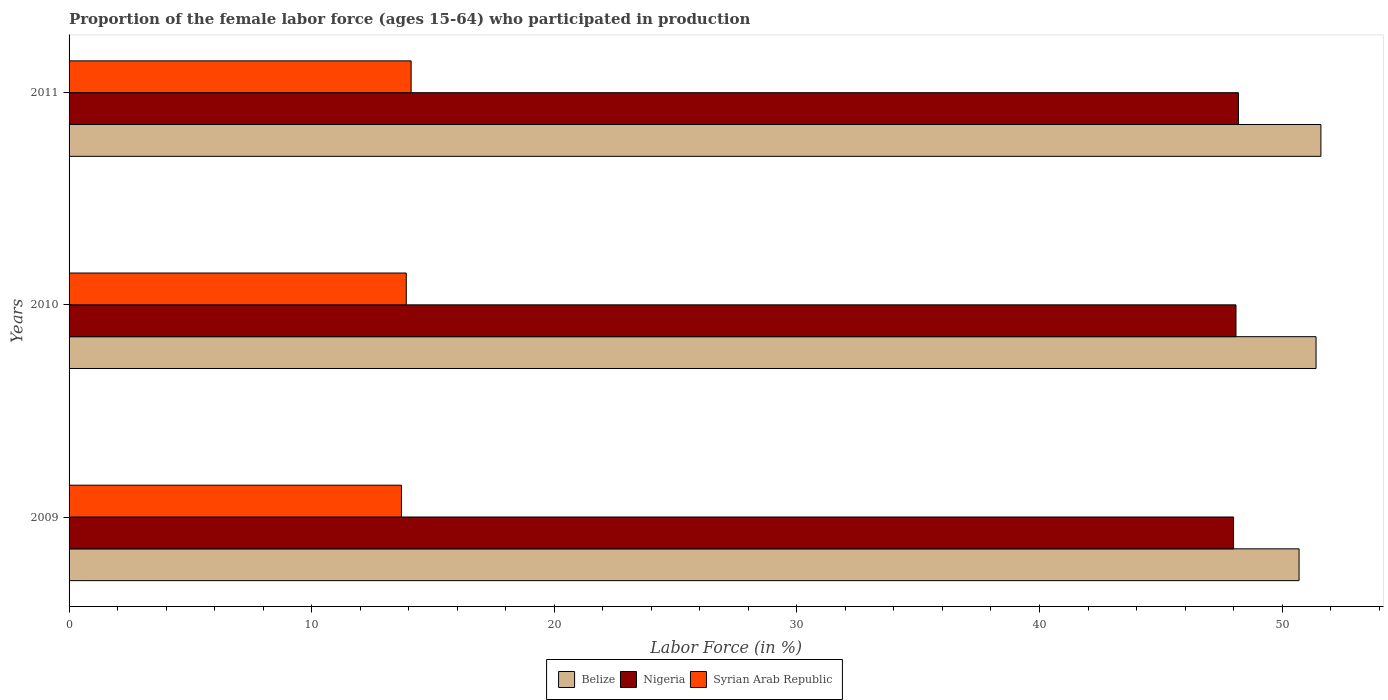How many bars are there on the 1st tick from the top?
Your response must be concise. 3. How many bars are there on the 3rd tick from the bottom?
Give a very brief answer. 3. What is the label of the 3rd group of bars from the top?
Your answer should be compact. 2009. In how many cases, is the number of bars for a given year not equal to the number of legend labels?
Your answer should be very brief. 0. What is the proportion of the female labor force who participated in production in Belize in 2010?
Provide a succinct answer. 51.4. Across all years, what is the maximum proportion of the female labor force who participated in production in Syrian Arab Republic?
Offer a very short reply. 14.1. Across all years, what is the minimum proportion of the female labor force who participated in production in Syrian Arab Republic?
Make the answer very short. 13.7. In which year was the proportion of the female labor force who participated in production in Belize maximum?
Give a very brief answer. 2011. What is the total proportion of the female labor force who participated in production in Nigeria in the graph?
Your response must be concise. 144.3. What is the difference between the proportion of the female labor force who participated in production in Syrian Arab Republic in 2009 and that in 2011?
Ensure brevity in your answer.  -0.4. What is the difference between the proportion of the female labor force who participated in production in Syrian Arab Republic in 2009 and the proportion of the female labor force who participated in production in Nigeria in 2011?
Make the answer very short. -34.5. What is the average proportion of the female labor force who participated in production in Belize per year?
Your answer should be compact. 51.23. In the year 2010, what is the difference between the proportion of the female labor force who participated in production in Syrian Arab Republic and proportion of the female labor force who participated in production in Nigeria?
Offer a very short reply. -34.2. In how many years, is the proportion of the female labor force who participated in production in Nigeria greater than 18 %?
Your response must be concise. 3. What is the ratio of the proportion of the female labor force who participated in production in Syrian Arab Republic in 2009 to that in 2010?
Provide a succinct answer. 0.99. Is the proportion of the female labor force who participated in production in Syrian Arab Republic in 2009 less than that in 2011?
Keep it short and to the point. Yes. What is the difference between the highest and the second highest proportion of the female labor force who participated in production in Nigeria?
Offer a very short reply. 0.1. What is the difference between the highest and the lowest proportion of the female labor force who participated in production in Syrian Arab Republic?
Provide a short and direct response. 0.4. What does the 3rd bar from the top in 2010 represents?
Keep it short and to the point. Belize. What does the 3rd bar from the bottom in 2010 represents?
Ensure brevity in your answer.  Syrian Arab Republic. Is it the case that in every year, the sum of the proportion of the female labor force who participated in production in Syrian Arab Republic and proportion of the female labor force who participated in production in Nigeria is greater than the proportion of the female labor force who participated in production in Belize?
Offer a very short reply. Yes. How many years are there in the graph?
Your answer should be very brief. 3. What is the difference between two consecutive major ticks on the X-axis?
Your response must be concise. 10. Does the graph contain any zero values?
Make the answer very short. No. Does the graph contain grids?
Make the answer very short. No. Where does the legend appear in the graph?
Offer a terse response. Bottom center. What is the title of the graph?
Your response must be concise. Proportion of the female labor force (ages 15-64) who participated in production. Does "Eritrea" appear as one of the legend labels in the graph?
Make the answer very short. No. What is the Labor Force (in %) of Belize in 2009?
Your response must be concise. 50.7. What is the Labor Force (in %) of Nigeria in 2009?
Ensure brevity in your answer.  48. What is the Labor Force (in %) of Syrian Arab Republic in 2009?
Provide a succinct answer. 13.7. What is the Labor Force (in %) in Belize in 2010?
Provide a short and direct response. 51.4. What is the Labor Force (in %) in Nigeria in 2010?
Make the answer very short. 48.1. What is the Labor Force (in %) in Syrian Arab Republic in 2010?
Your answer should be very brief. 13.9. What is the Labor Force (in %) of Belize in 2011?
Offer a terse response. 51.6. What is the Labor Force (in %) in Nigeria in 2011?
Give a very brief answer. 48.2. What is the Labor Force (in %) of Syrian Arab Republic in 2011?
Make the answer very short. 14.1. Across all years, what is the maximum Labor Force (in %) in Belize?
Your response must be concise. 51.6. Across all years, what is the maximum Labor Force (in %) of Nigeria?
Your response must be concise. 48.2. Across all years, what is the maximum Labor Force (in %) of Syrian Arab Republic?
Give a very brief answer. 14.1. Across all years, what is the minimum Labor Force (in %) in Belize?
Make the answer very short. 50.7. Across all years, what is the minimum Labor Force (in %) of Syrian Arab Republic?
Offer a terse response. 13.7. What is the total Labor Force (in %) of Belize in the graph?
Make the answer very short. 153.7. What is the total Labor Force (in %) of Nigeria in the graph?
Offer a terse response. 144.3. What is the total Labor Force (in %) in Syrian Arab Republic in the graph?
Ensure brevity in your answer.  41.7. What is the difference between the Labor Force (in %) in Syrian Arab Republic in 2009 and that in 2010?
Keep it short and to the point. -0.2. What is the difference between the Labor Force (in %) of Belize in 2009 and that in 2011?
Offer a very short reply. -0.9. What is the difference between the Labor Force (in %) of Syrian Arab Republic in 2009 and that in 2011?
Provide a short and direct response. -0.4. What is the difference between the Labor Force (in %) of Nigeria in 2010 and that in 2011?
Keep it short and to the point. -0.1. What is the difference between the Labor Force (in %) in Belize in 2009 and the Labor Force (in %) in Syrian Arab Republic in 2010?
Your answer should be compact. 36.8. What is the difference between the Labor Force (in %) of Nigeria in 2009 and the Labor Force (in %) of Syrian Arab Republic in 2010?
Offer a very short reply. 34.1. What is the difference between the Labor Force (in %) in Belize in 2009 and the Labor Force (in %) in Nigeria in 2011?
Make the answer very short. 2.5. What is the difference between the Labor Force (in %) in Belize in 2009 and the Labor Force (in %) in Syrian Arab Republic in 2011?
Offer a very short reply. 36.6. What is the difference between the Labor Force (in %) of Nigeria in 2009 and the Labor Force (in %) of Syrian Arab Republic in 2011?
Make the answer very short. 33.9. What is the difference between the Labor Force (in %) of Belize in 2010 and the Labor Force (in %) of Syrian Arab Republic in 2011?
Provide a succinct answer. 37.3. What is the average Labor Force (in %) in Belize per year?
Make the answer very short. 51.23. What is the average Labor Force (in %) of Nigeria per year?
Provide a succinct answer. 48.1. What is the average Labor Force (in %) in Syrian Arab Republic per year?
Your answer should be very brief. 13.9. In the year 2009, what is the difference between the Labor Force (in %) of Belize and Labor Force (in %) of Nigeria?
Give a very brief answer. 2.7. In the year 2009, what is the difference between the Labor Force (in %) in Nigeria and Labor Force (in %) in Syrian Arab Republic?
Provide a succinct answer. 34.3. In the year 2010, what is the difference between the Labor Force (in %) of Belize and Labor Force (in %) of Nigeria?
Ensure brevity in your answer.  3.3. In the year 2010, what is the difference between the Labor Force (in %) of Belize and Labor Force (in %) of Syrian Arab Republic?
Your response must be concise. 37.5. In the year 2010, what is the difference between the Labor Force (in %) of Nigeria and Labor Force (in %) of Syrian Arab Republic?
Provide a succinct answer. 34.2. In the year 2011, what is the difference between the Labor Force (in %) in Belize and Labor Force (in %) in Nigeria?
Your response must be concise. 3.4. In the year 2011, what is the difference between the Labor Force (in %) in Belize and Labor Force (in %) in Syrian Arab Republic?
Make the answer very short. 37.5. In the year 2011, what is the difference between the Labor Force (in %) of Nigeria and Labor Force (in %) of Syrian Arab Republic?
Provide a short and direct response. 34.1. What is the ratio of the Labor Force (in %) in Belize in 2009 to that in 2010?
Keep it short and to the point. 0.99. What is the ratio of the Labor Force (in %) in Nigeria in 2009 to that in 2010?
Your answer should be compact. 1. What is the ratio of the Labor Force (in %) of Syrian Arab Republic in 2009 to that in 2010?
Provide a short and direct response. 0.99. What is the ratio of the Labor Force (in %) of Belize in 2009 to that in 2011?
Your response must be concise. 0.98. What is the ratio of the Labor Force (in %) of Nigeria in 2009 to that in 2011?
Your answer should be very brief. 1. What is the ratio of the Labor Force (in %) in Syrian Arab Republic in 2009 to that in 2011?
Ensure brevity in your answer.  0.97. What is the ratio of the Labor Force (in %) in Belize in 2010 to that in 2011?
Offer a very short reply. 1. What is the ratio of the Labor Force (in %) in Syrian Arab Republic in 2010 to that in 2011?
Ensure brevity in your answer.  0.99. What is the difference between the highest and the second highest Labor Force (in %) in Belize?
Make the answer very short. 0.2. What is the difference between the highest and the second highest Labor Force (in %) of Syrian Arab Republic?
Your answer should be compact. 0.2. What is the difference between the highest and the lowest Labor Force (in %) of Syrian Arab Republic?
Your response must be concise. 0.4. 